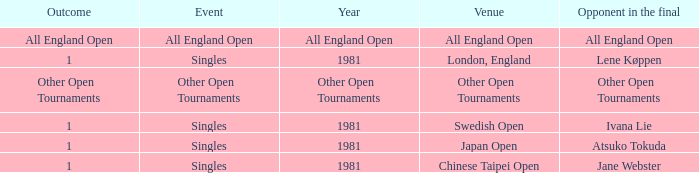What is the Outcome when All England Open is the Opponent in the final? All England Open. 